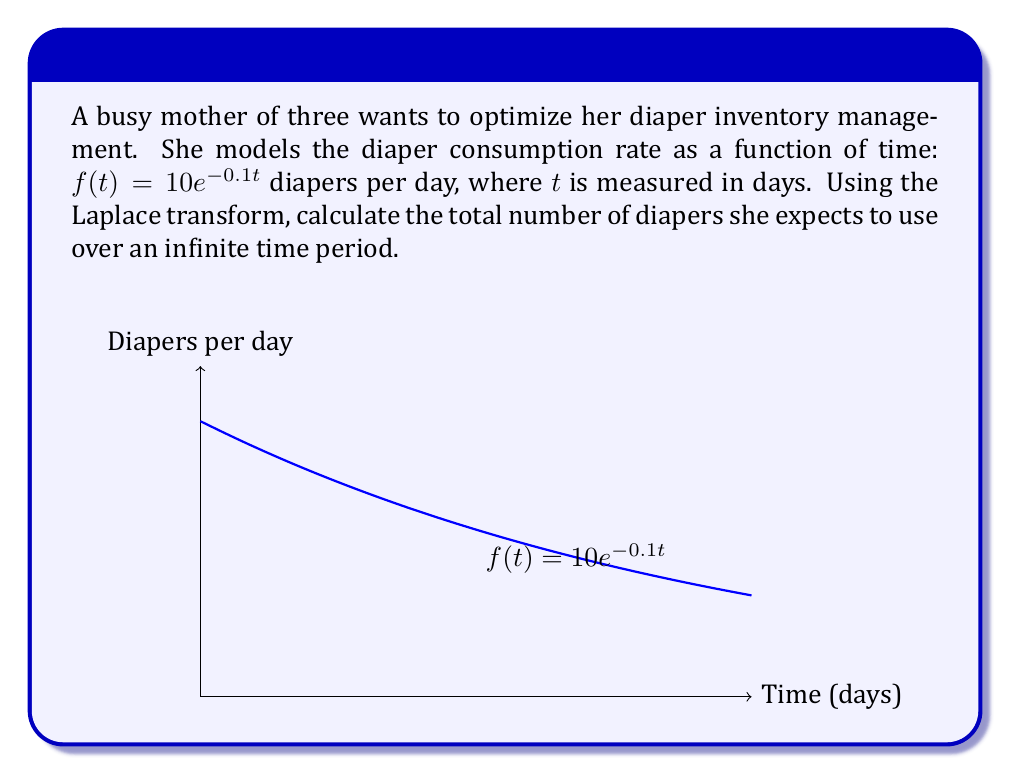Solve this math problem. Let's approach this step-by-step using the Laplace transform:

1) The Laplace transform of $f(t)$ is given by:
   $$F(s) = \mathcal{L}\{f(t)\} = \int_0^{\infty} f(t)e^{-st} dt$$

2) In this case, $f(t) = 10e^{-0.1t}$, so we have:
   $$F(s) = \int_0^{\infty} 10e^{-0.1t}e^{-st} dt = 10\int_0^{\infty} e^{-(s+0.1)t} dt$$

3) Evaluating this integral:
   $$F(s) = 10 \left[-\frac{1}{s+0.1}e^{-(s+0.1)t}\right]_0^{\infty} = 10 \left[0 - \left(-\frac{1}{s+0.1}\right)\right] = \frac{10}{s+0.1}$$

4) To find the total number of diapers used over an infinite time period, we need to evaluate $F(s)$ at $s=0$:
   $$\text{Total diapers} = F(0) = \frac{10}{0+0.1} = \frac{10}{0.1} = 100$$

This result makes sense intuitively: the initial rate of 10 diapers per day decreases exponentially, and the total over infinite time is finite due to the exponential decay.
Answer: 100 diapers 